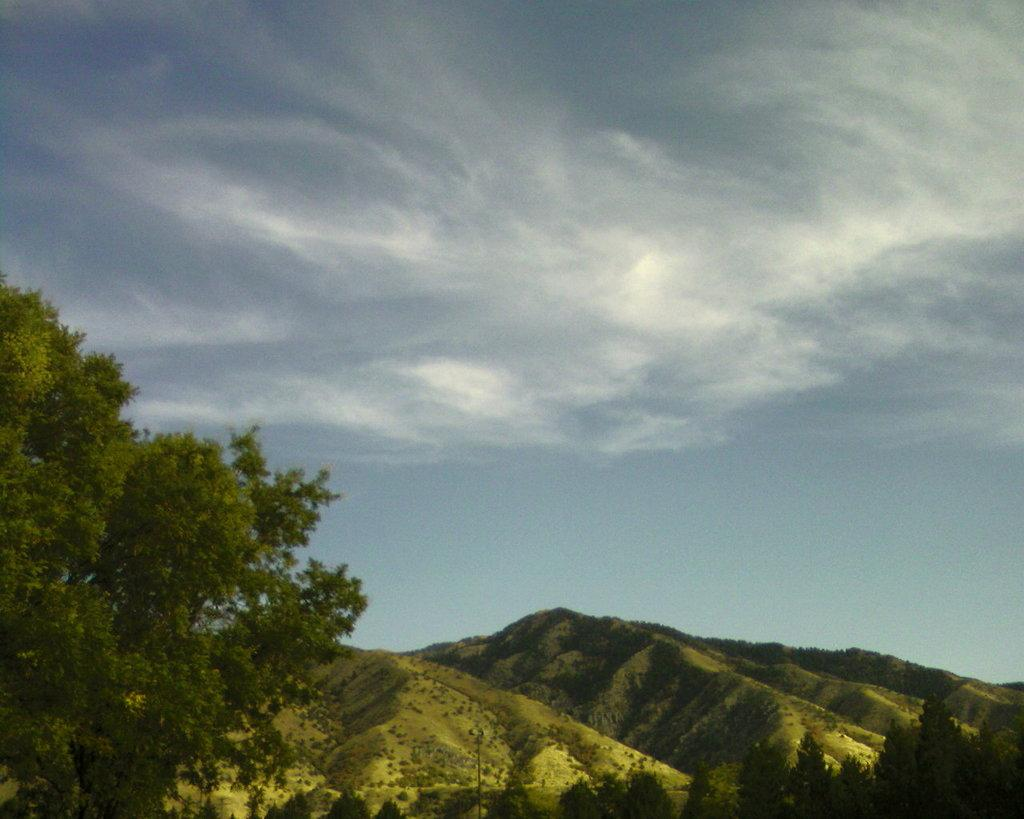What type of natural features can be seen in the image? There are trees and mountains in the image. What part of the natural environment is visible in the image? The sky is visible in the image. What sense does the representative use to say good-bye in the image? There is no representative or good-bye gesture present in the image; it features trees, mountains, and the sky. 